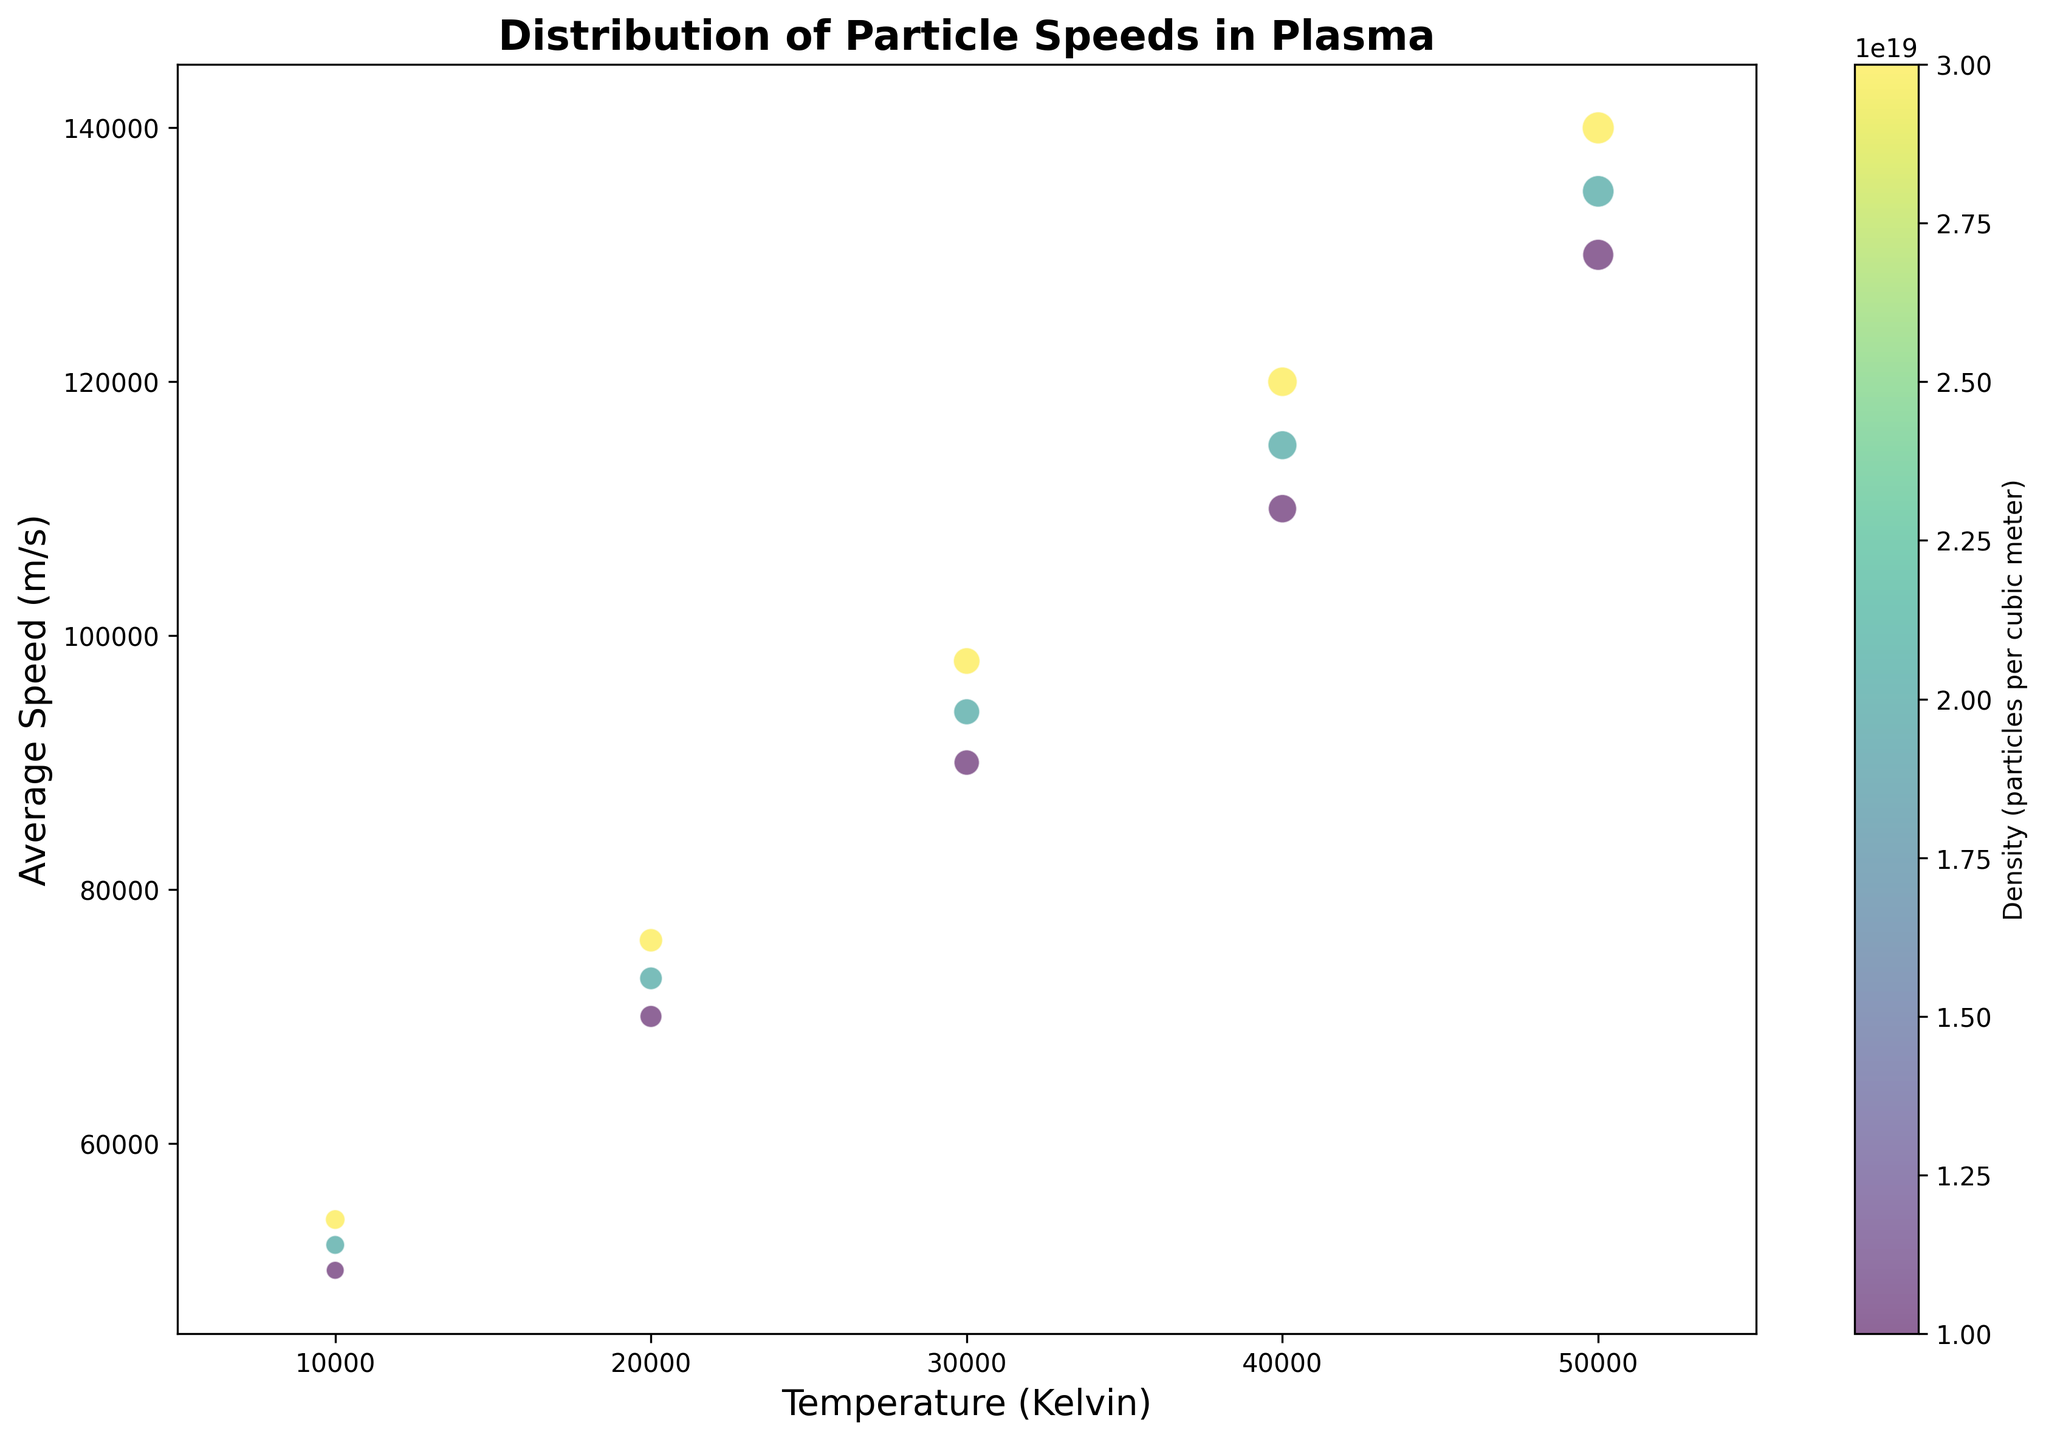What temperature range is covered in the plot? Examine the x-axis labels. The temperature ranges from 10000 to 50000 Kelvin.
Answer: 10000 to 50000 Kelvin Which temperature has the highest average particle speed? Look at the highest point on the y-axis and check its corresponding x-axis value. The highest average speed is at 50000 K.
Answer: 50000 Kelvin For a plasma density of 2e19 particles per cubic meter, what is the average speed of particles at 30000 Kelvin? Trace vertically up from 30000 K on the x-axis to where it intersects the bubbles. The color bar indicates the density, and the corresponding average speed can be read off the y-axis. The average speed is approximately 94000 m/s.
Answer: 94000 m/s What is the general trend between temperature and average particle speed? Observe the overall direction of the bubbles from the left side to the right side of the plot. As temperature increases, the average speed of particles also increases.
Answer: Increasing How does the variance of particle speeds change with temperature? Look at the size of the bubbles as temperature increases. Bubbles get larger as temperature increases, indicating an increase in the variance of particle speeds.
Answer: Increasing At which temperature is the difference in average particle speeds between densities 1e19 and 3e19 particles per cubic meter the greatest? Compare the vertical distances between the bubbles corresponding to densities 1e19 and 3e19 at each temperature. The difference is greatest at 50000 K.
Answer: 50000 Kelvin Which density corresponds to the darkest color on the plot? Refer to the color bar and find the darkest shade, then compare it with the density values. The darkest color corresponds to a density of 3e19 particles per cubic meter.
Answer: 3e19 particles per cubic meter What can be inferred about the variance in particle speeds at 20000 K and a density of 2e19 particles per cubic meter? Check the size of the bubble at the intersection of 20000 K on the x-axis and the density color corresponding to 2e19. The bubble size represents the variance, which is 1600.
Answer: 1600 Compare the average speed of particles at 40000 K and a density of 3e19 particles per cubic meter with that at 30000 K and a density of 1e19 particles per cubic meter. Which is higher? Locate the bubbles for these specific conditions and compare their y-axis values. The bubble for 40000 K and 3e19 has an average speed of 120000 m/s, whereas the bubble for 30000 K and 1e19 has 90000 m/s. 120000 m/s is higher.
Answer: 120000 m/s For a constant temperature of 10000 K, how does the average speed of particles change as density increases from 1e19 to 3e19 particles per cubic meter? Examine the bubbles at 10000 K for each density. The average speeds increase from 50000 m/s to 54000 m/s as density goes from 1e19 to 3e19.
Answer: Increasing 